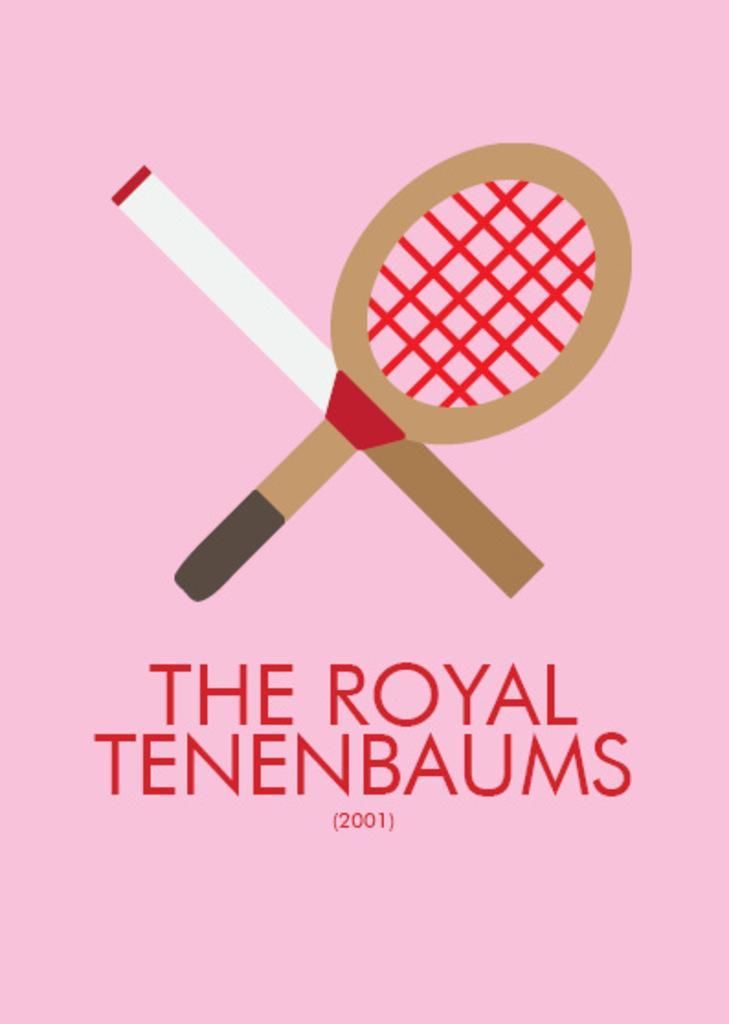In one or two sentences, can you explain what this image depicts? This is a poster. In this image there is something written. Also there is a drawing of a tennis bat. In the background it is pink color. 